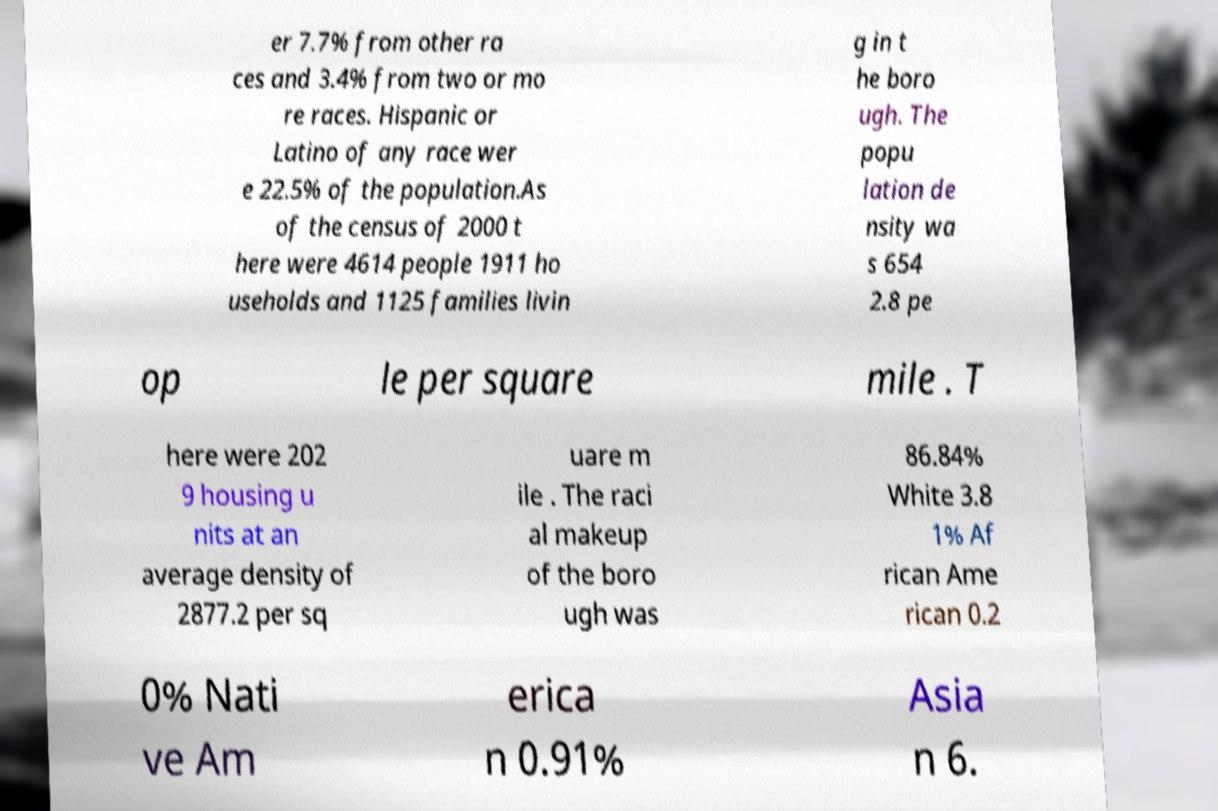Could you assist in decoding the text presented in this image and type it out clearly? er 7.7% from other ra ces and 3.4% from two or mo re races. Hispanic or Latino of any race wer e 22.5% of the population.As of the census of 2000 t here were 4614 people 1911 ho useholds and 1125 families livin g in t he boro ugh. The popu lation de nsity wa s 654 2.8 pe op le per square mile . T here were 202 9 housing u nits at an average density of 2877.2 per sq uare m ile . The raci al makeup of the boro ugh was 86.84% White 3.8 1% Af rican Ame rican 0.2 0% Nati ve Am erica n 0.91% Asia n 6. 